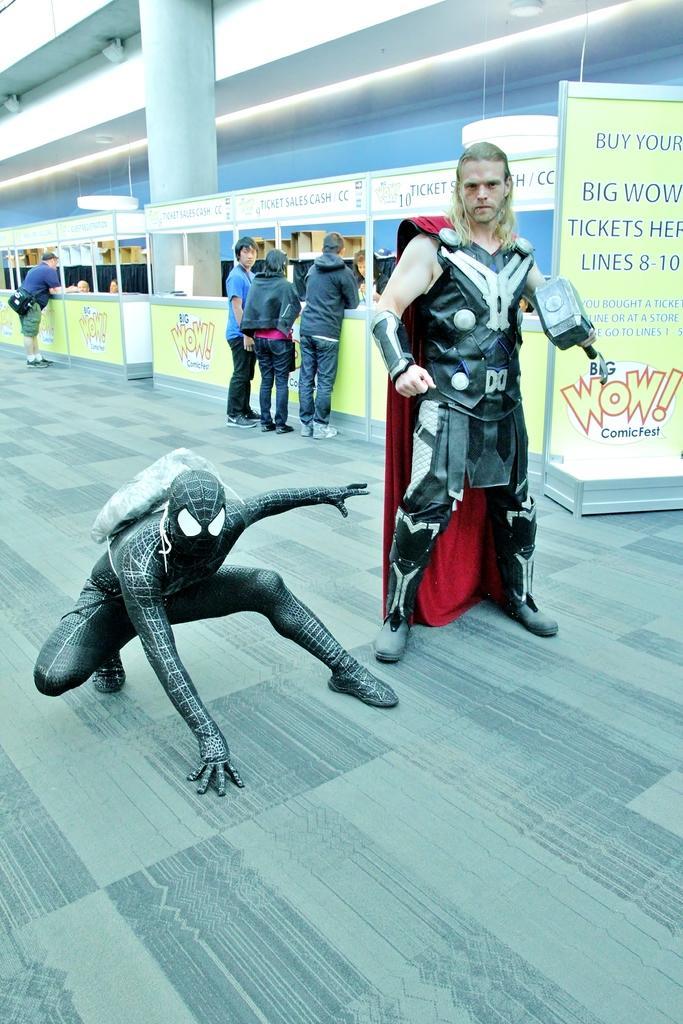How would you summarize this image in a sentence or two? In this picture I can see on the right side there is a board, in the middle there is a man in costume. On the left side it looks like a doll in the shape of a spider-man, in the background few persons are standing near the stalls, at the top there are lights. 